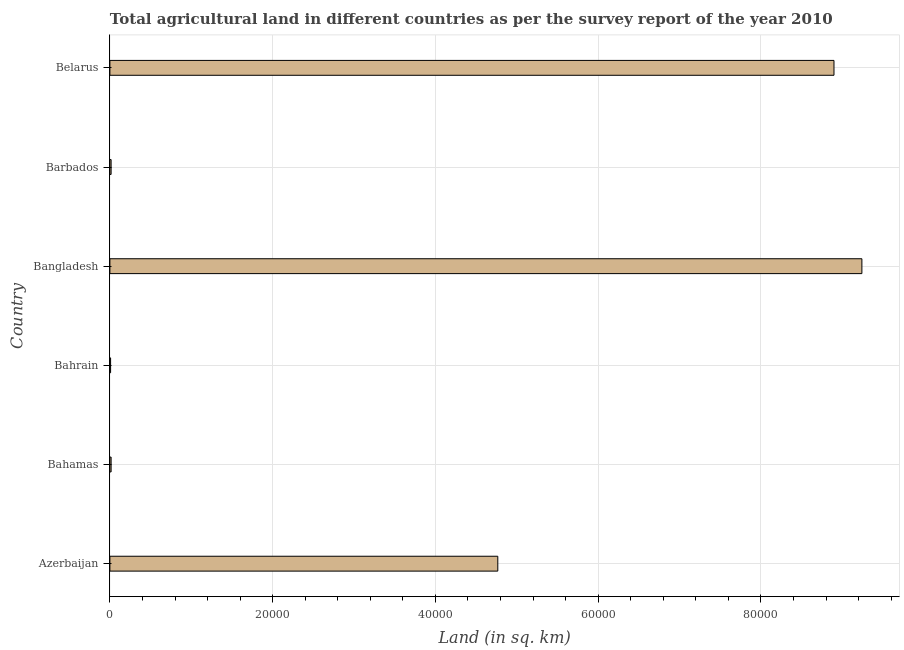What is the title of the graph?
Your response must be concise. Total agricultural land in different countries as per the survey report of the year 2010. What is the label or title of the X-axis?
Your answer should be very brief. Land (in sq. km). What is the label or title of the Y-axis?
Offer a very short reply. Country. What is the agricultural land in Bahamas?
Your response must be concise. 150. Across all countries, what is the maximum agricultural land?
Your response must be concise. 9.24e+04. Across all countries, what is the minimum agricultural land?
Offer a terse response. 86. In which country was the agricultural land minimum?
Your answer should be compact. Bahrain. What is the sum of the agricultural land?
Ensure brevity in your answer.  2.29e+05. What is the difference between the agricultural land in Bangladesh and Barbados?
Ensure brevity in your answer.  9.23e+04. What is the average agricultural land per country?
Provide a succinct answer. 3.82e+04. What is the median agricultural land?
Give a very brief answer. 2.39e+04. In how many countries, is the agricultural land greater than 48000 sq. km?
Give a very brief answer. 2. What is the ratio of the agricultural land in Azerbaijan to that in Bahamas?
Make the answer very short. 317.79. Is the difference between the agricultural land in Bahrain and Belarus greater than the difference between any two countries?
Make the answer very short. No. What is the difference between the highest and the second highest agricultural land?
Your answer should be very brief. 3430. Is the sum of the agricultural land in Bahamas and Barbados greater than the maximum agricultural land across all countries?
Your answer should be very brief. No. What is the difference between the highest and the lowest agricultural land?
Provide a succinct answer. 9.23e+04. How many bars are there?
Offer a terse response. 6. What is the difference between two consecutive major ticks on the X-axis?
Your response must be concise. 2.00e+04. What is the Land (in sq. km) of Azerbaijan?
Keep it short and to the point. 4.77e+04. What is the Land (in sq. km) in Bahamas?
Make the answer very short. 150. What is the Land (in sq. km) of Bahrain?
Keep it short and to the point. 86. What is the Land (in sq. km) in Bangladesh?
Give a very brief answer. 9.24e+04. What is the Land (in sq. km) in Barbados?
Provide a succinct answer. 150. What is the Land (in sq. km) of Belarus?
Your response must be concise. 8.90e+04. What is the difference between the Land (in sq. km) in Azerbaijan and Bahamas?
Your response must be concise. 4.75e+04. What is the difference between the Land (in sq. km) in Azerbaijan and Bahrain?
Provide a succinct answer. 4.76e+04. What is the difference between the Land (in sq. km) in Azerbaijan and Bangladesh?
Keep it short and to the point. -4.47e+04. What is the difference between the Land (in sq. km) in Azerbaijan and Barbados?
Keep it short and to the point. 4.75e+04. What is the difference between the Land (in sq. km) in Azerbaijan and Belarus?
Offer a very short reply. -4.13e+04. What is the difference between the Land (in sq. km) in Bahamas and Bahrain?
Provide a succinct answer. 64. What is the difference between the Land (in sq. km) in Bahamas and Bangladesh?
Keep it short and to the point. -9.23e+04. What is the difference between the Land (in sq. km) in Bahamas and Barbados?
Ensure brevity in your answer.  0. What is the difference between the Land (in sq. km) in Bahamas and Belarus?
Your answer should be compact. -8.88e+04. What is the difference between the Land (in sq. km) in Bahrain and Bangladesh?
Your answer should be compact. -9.23e+04. What is the difference between the Land (in sq. km) in Bahrain and Barbados?
Offer a very short reply. -64. What is the difference between the Land (in sq. km) in Bahrain and Belarus?
Provide a succinct answer. -8.89e+04. What is the difference between the Land (in sq. km) in Bangladesh and Barbados?
Give a very brief answer. 9.23e+04. What is the difference between the Land (in sq. km) in Bangladesh and Belarus?
Provide a short and direct response. 3430. What is the difference between the Land (in sq. km) in Barbados and Belarus?
Provide a succinct answer. -8.88e+04. What is the ratio of the Land (in sq. km) in Azerbaijan to that in Bahamas?
Give a very brief answer. 317.79. What is the ratio of the Land (in sq. km) in Azerbaijan to that in Bahrain?
Your answer should be very brief. 554.28. What is the ratio of the Land (in sq. km) in Azerbaijan to that in Bangladesh?
Offer a very short reply. 0.52. What is the ratio of the Land (in sq. km) in Azerbaijan to that in Barbados?
Your response must be concise. 317.79. What is the ratio of the Land (in sq. km) in Azerbaijan to that in Belarus?
Give a very brief answer. 0.54. What is the ratio of the Land (in sq. km) in Bahamas to that in Bahrain?
Ensure brevity in your answer.  1.74. What is the ratio of the Land (in sq. km) in Bahamas to that in Bangladesh?
Provide a succinct answer. 0. What is the ratio of the Land (in sq. km) in Bahamas to that in Belarus?
Provide a short and direct response. 0. What is the ratio of the Land (in sq. km) in Bahrain to that in Barbados?
Provide a succinct answer. 0.57. What is the ratio of the Land (in sq. km) in Bahrain to that in Belarus?
Provide a succinct answer. 0. What is the ratio of the Land (in sq. km) in Bangladesh to that in Barbados?
Offer a very short reply. 616.07. What is the ratio of the Land (in sq. km) in Bangladesh to that in Belarus?
Your answer should be very brief. 1.04. What is the ratio of the Land (in sq. km) in Barbados to that in Belarus?
Offer a very short reply. 0. 